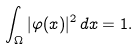<formula> <loc_0><loc_0><loc_500><loc_500>\int _ { \Omega } | \varphi ( x ) | ^ { 2 } \, d x = 1 .</formula> 